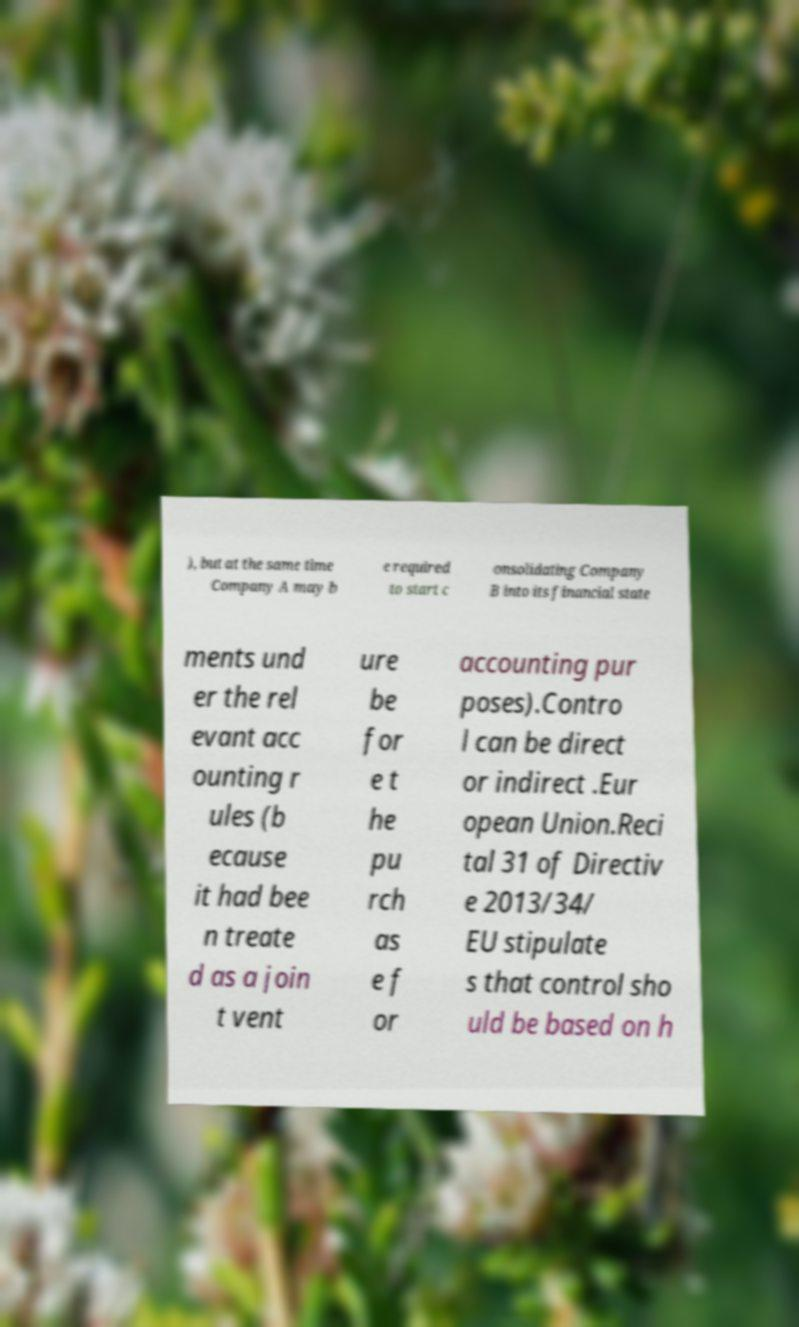Can you read and provide the text displayed in the image?This photo seems to have some interesting text. Can you extract and type it out for me? ), but at the same time Company A may b e required to start c onsolidating Company B into its financial state ments und er the rel evant acc ounting r ules (b ecause it had bee n treate d as a join t vent ure be for e t he pu rch as e f or accounting pur poses).Contro l can be direct or indirect .Eur opean Union.Reci tal 31 of Directiv e 2013/34/ EU stipulate s that control sho uld be based on h 